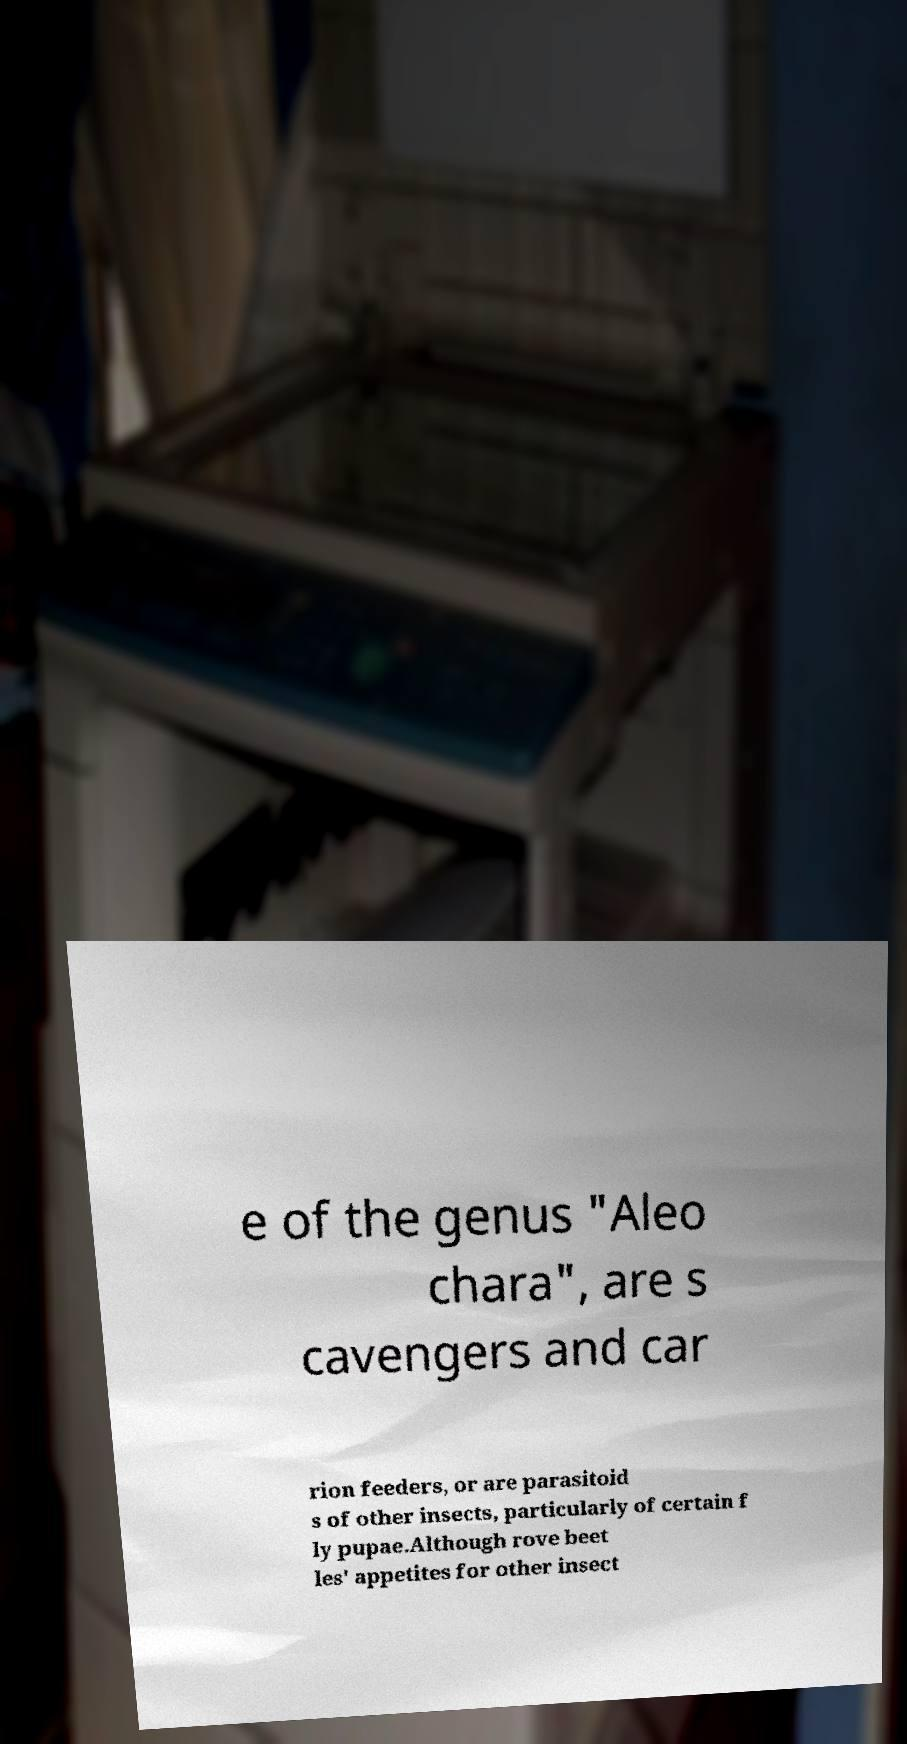Can you accurately transcribe the text from the provided image for me? e of the genus "Aleo chara", are s cavengers and car rion feeders, or are parasitoid s of other insects, particularly of certain f ly pupae.Although rove beet les' appetites for other insect 